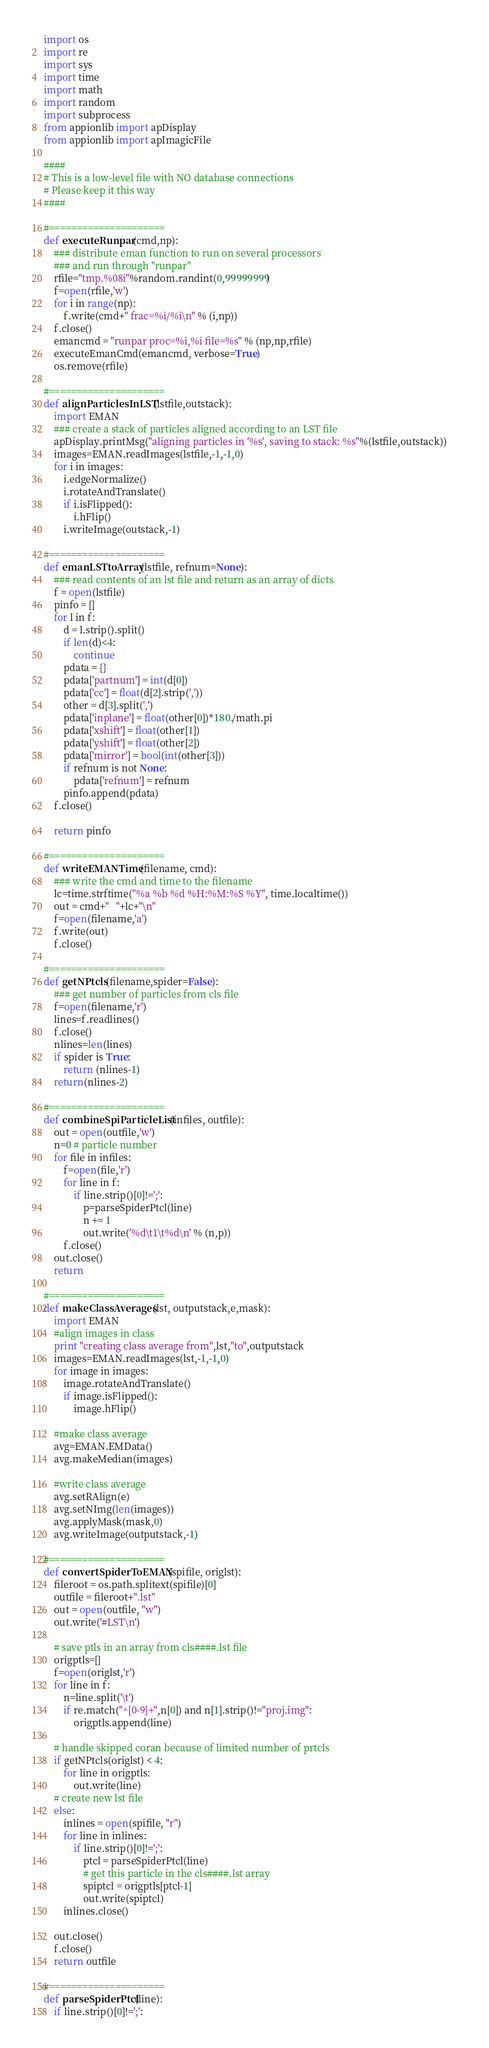Convert code to text. <code><loc_0><loc_0><loc_500><loc_500><_Python_>import os
import re
import sys
import time
import math
import random
import subprocess
from appionlib import apDisplay
from appionlib import apImagicFile

####
# This is a low-level file with NO database connections
# Please keep it this way
####

#=====================
def executeRunpar(cmd,np):
	### distribute eman function to run on several processors
	### and run through "runpar"
	rfile="tmp.%08i"%random.randint(0,99999999)
	f=open(rfile,'w')
	for i in range(np):
		f.write(cmd+" frac=%i/%i\n" % (i,np))
	f.close()
	emancmd = "runpar proc=%i,%i file=%s" % (np,np,rfile)
	executeEmanCmd(emancmd, verbose=True)
	os.remove(rfile)	

#=====================
def alignParticlesInLST(lstfile,outstack):
	import EMAN
	### create a stack of particles aligned according to an LST file
	apDisplay.printMsg("aligning particles in '%s', saving to stack: %s"%(lstfile,outstack))	
	images=EMAN.readImages(lstfile,-1,-1,0)
	for i in images:
		i.edgeNormalize()
		i.rotateAndTranslate()
		if i.isFlipped():
			i.hFlip()
		i.writeImage(outstack,-1)

#=====================
def emanLSTtoArray(lstfile, refnum=None):
	### read contents of an lst file and return as an array of dicts
	f = open(lstfile)
	pinfo = []
	for l in f:
		d = l.strip().split()
		if len(d)<4:
			continue
		pdata = {}
		pdata['partnum'] = int(d[0])
		pdata['cc'] = float(d[2].strip(','))
		other = d[3].split(',')
		pdata['inplane'] = float(other[0])*180./math.pi
		pdata['xshift'] = float(other[1])
		pdata['yshift'] = float(other[2])
		pdata['mirror'] = bool(int(other[3]))
		if refnum is not None:
			pdata['refnum'] = refnum
		pinfo.append(pdata)
	f.close()

	return pinfo

#=====================
def writeEMANTime(filename, cmd):
	### write the cmd and time to the filename
	lc=time.strftime("%a %b %d %H:%M:%S %Y", time.localtime())
	out = cmd+"   "+lc+"\n"
	f=open(filename,'a')
	f.write(out)
	f.close()

#=====================
def getNPtcls(filename,spider=False):
	### get number of particles from cls file
	f=open(filename,'r')
	lines=f.readlines()
	f.close()
	nlines=len(lines)
	if spider is True:
		return (nlines-1)
	return(nlines-2)

#=====================
def combineSpiParticleList(infiles, outfile):
	out = open(outfile,'w')
	n=0 # particle number
	for file in infiles:
		f=open(file,'r')
		for line in f:
			if line.strip()[0]!=';':
				p=parseSpiderPtcl(line)
				n += 1
				out.write('%d\t1\t%d\n' % (n,p))
		f.close()
	out.close()
	return

#=====================
def makeClassAverages(lst, outputstack,e,mask):
	import EMAN
	#align images in class
	print "creating class average from",lst,"to",outputstack
	images=EMAN.readImages(lst,-1,-1,0)
	for image in images:
		image.rotateAndTranslate()
		if image.isFlipped():
			image.hFlip()

	#make class average
	avg=EMAN.EMData()
	avg.makeMedian(images)

	#write class average
	avg.setRAlign(e)
	avg.setNImg(len(images))
	avg.applyMask(mask,0)
	avg.writeImage(outputstack,-1)

#=====================
def convertSpiderToEMAN(spifile, origlst):
	fileroot = os.path.splitext(spifile)[0]
	outfile = fileroot+".lst"
	out = open(outfile, "w")
	out.write('#LST\n')

	# save ptls in an array from cls####.lst file
	origptls=[]
	f=open(origlst,'r')
	for line in f:
		n=line.split('\t')
		if re.match("^[0-9]+",n[0]) and n[1].strip()!="proj.img":
			origptls.append(line)

	# handle skipped coran because of limited number of prtcls
	if getNPtcls(origlst) < 4:
		for line in origptls:
			out.write(line)
	# create new lst file
	else:
		inlines = open(spifile, "r")
		for line in inlines:
			if line.strip()[0]!=';':
				ptcl = parseSpiderPtcl(line)
				# get this particle in the cls####.lst array
				spiptcl = origptls[ptcl-1]
				out.write(spiptcl)
		inlines.close()

	out.close()
	f.close()
	return outfile

#=====================
def parseSpiderPtcl(line):
	if line.strip()[0]!=';':</code> 